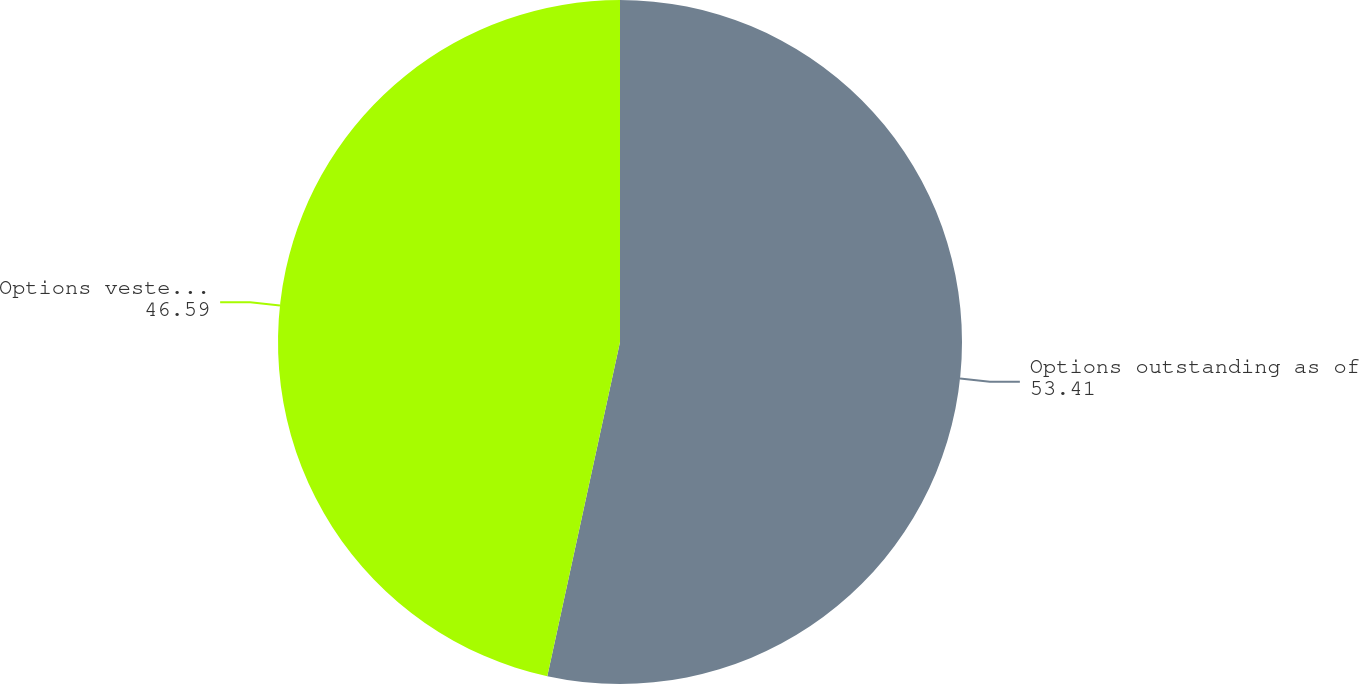<chart> <loc_0><loc_0><loc_500><loc_500><pie_chart><fcel>Options outstanding as of<fcel>Options vested as of December<nl><fcel>53.41%<fcel>46.59%<nl></chart> 